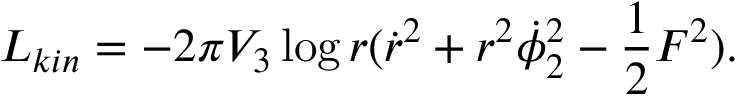Convert formula to latex. <formula><loc_0><loc_0><loc_500><loc_500>L _ { k i n } = - 2 \pi V _ { 3 } \log r ( { \dot { r } } ^ { 2 } + r ^ { 2 } \dot { \phi } _ { 2 } ^ { 2 } - { \frac { 1 } { 2 } } F ^ { 2 } ) .</formula> 